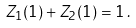<formula> <loc_0><loc_0><loc_500><loc_500>Z _ { 1 } ( 1 ) + Z _ { 2 } ( 1 ) = 1 \, .</formula> 